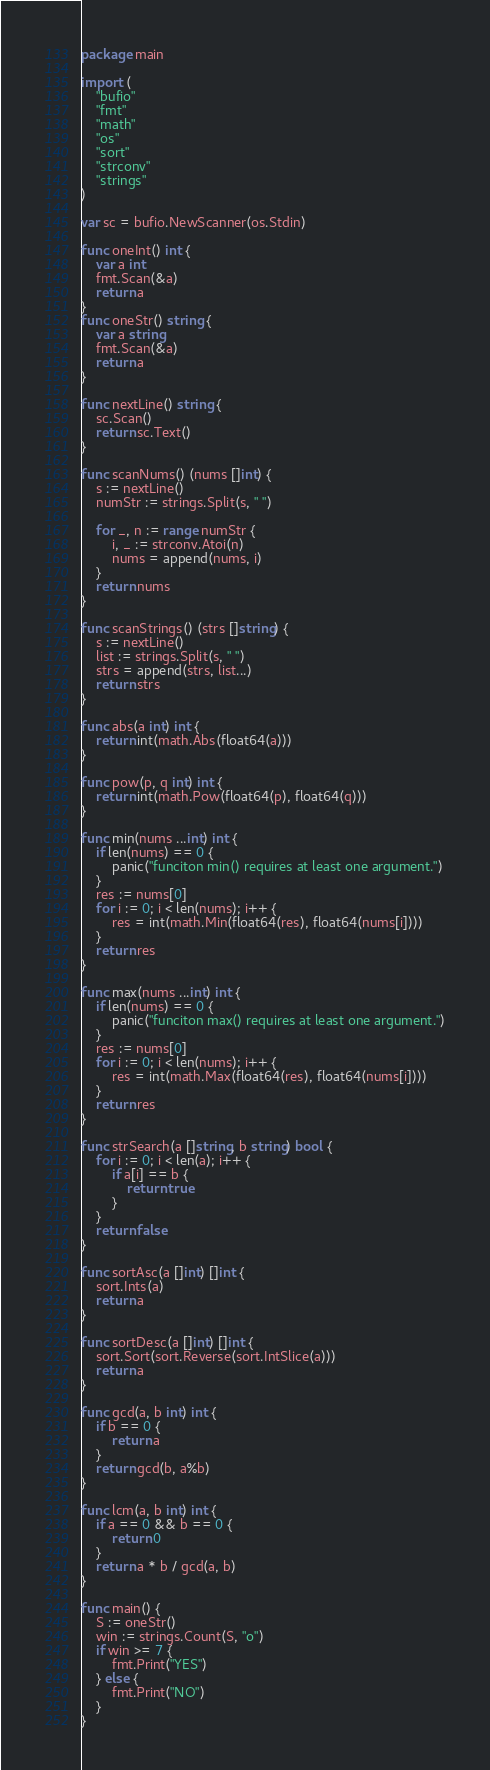<code> <loc_0><loc_0><loc_500><loc_500><_Go_>package main

import (
	"bufio"
	"fmt"
	"math"
	"os"
	"sort"
	"strconv"
	"strings"
)

var sc = bufio.NewScanner(os.Stdin)

func oneInt() int {
	var a int
	fmt.Scan(&a)
	return a
}
func oneStr() string {
	var a string
	fmt.Scan(&a)
	return a
}

func nextLine() string {
	sc.Scan()
	return sc.Text()
}

func scanNums() (nums []int) {
	s := nextLine()
	numStr := strings.Split(s, " ")

	for _, n := range numStr {
		i, _ := strconv.Atoi(n)
		nums = append(nums, i)
	}
	return nums
}

func scanStrings() (strs []string) {
	s := nextLine()
	list := strings.Split(s, " ")
	strs = append(strs, list...)
	return strs
}

func abs(a int) int {
	return int(math.Abs(float64(a)))
}

func pow(p, q int) int {
	return int(math.Pow(float64(p), float64(q)))
}

func min(nums ...int) int {
	if len(nums) == 0 {
		panic("funciton min() requires at least one argument.")
	}
	res := nums[0]
	for i := 0; i < len(nums); i++ {
		res = int(math.Min(float64(res), float64(nums[i])))
	}
	return res
}

func max(nums ...int) int {
	if len(nums) == 0 {
		panic("funciton max() requires at least one argument.")
	}
	res := nums[0]
	for i := 0; i < len(nums); i++ {
		res = int(math.Max(float64(res), float64(nums[i])))
	}
	return res
}

func strSearch(a []string, b string) bool {
	for i := 0; i < len(a); i++ {
		if a[i] == b {
			return true
		}
	}
	return false
}

func sortAsc(a []int) []int {
	sort.Ints(a)
	return a
}

func sortDesc(a []int) []int {
	sort.Sort(sort.Reverse(sort.IntSlice(a)))
	return a
}

func gcd(a, b int) int {
	if b == 0 {
		return a
	}
	return gcd(b, a%b)
}

func lcm(a, b int) int {
	if a == 0 && b == 0 {
		return 0
	}
	return a * b / gcd(a, b)
}

func main() {
	S := oneStr()
	win := strings.Count(S, "o")
	if win >= 7 {
		fmt.Print("YES")
	} else {
		fmt.Print("NO")
	}
}
</code> 